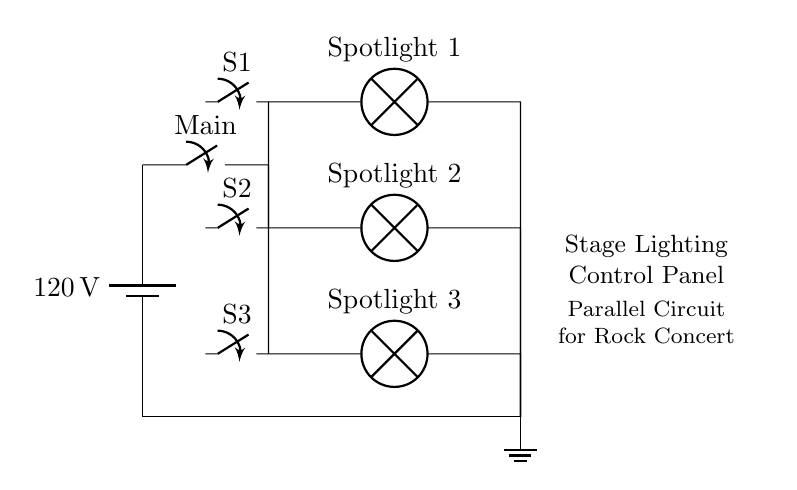What is the voltage provided by the power source? The power source is labeled as 120V, which indicates the potential difference across the terminals.
Answer: 120V What components are used in the parallel circuit? The main components are a battery, switches, and three lamps labeled as Spotlight 1, Spotlight 2, and Spotlight 3, connected in parallel.
Answer: Battery, switches, lamps How many individual switches are present in the circuit? The diagram shows three individual switches, S1, S2, and S3, each connected to their respective spotlight lamps.
Answer: Three What happens to the other spotlights if one spotlight is turned off? Because the spotlights are connected in parallel, the other spotlights will remain lit when one is turned off, due to independent paths for current flow.
Answer: Remain lit If the total current entering the circuit is 10A, how is that current shared among the spotlights? In a parallel circuit, the total current splits among the branches. If the lamps have different resistances, the current through each will depend on their resistance values. The sum of the individual currents equals the total current (10A).
Answer: Varies Which component controls the main circuit power? The main switch labeled as "Main" controls the overall electrical flow from the power source to the parallel branches containing the spotlights.
Answer: Main switch What is the purpose of having a parallel configuration for stage lighting? The parallel configuration allows for independent control of each spotlight and ensures that failure of one lamp does not affect the others, providing reliability during performances.
Answer: Independent control 